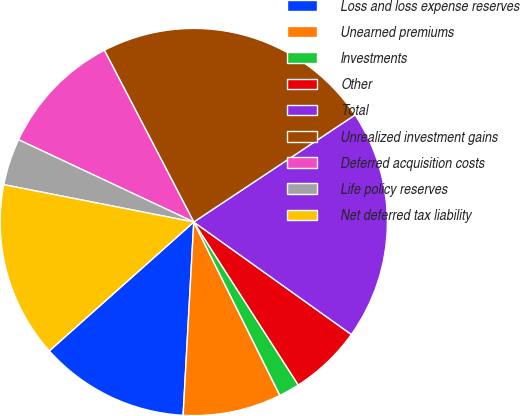<chart> <loc_0><loc_0><loc_500><loc_500><pie_chart><fcel>Loss and loss expense reserves<fcel>Unearned premiums<fcel>Investments<fcel>Other<fcel>Total<fcel>Unrealized investment gains<fcel>Deferred acquisition costs<fcel>Life policy reserves<fcel>Net deferred tax liability<nl><fcel>12.53%<fcel>8.21%<fcel>1.74%<fcel>6.06%<fcel>19.19%<fcel>23.31%<fcel>10.37%<fcel>3.9%<fcel>14.68%<nl></chart> 